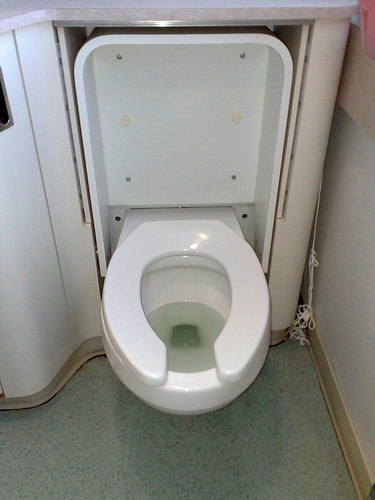Describe the objects in this image and their specific colors. I can see a toilet in darkgray, lightgray, and gray tones in this image. 